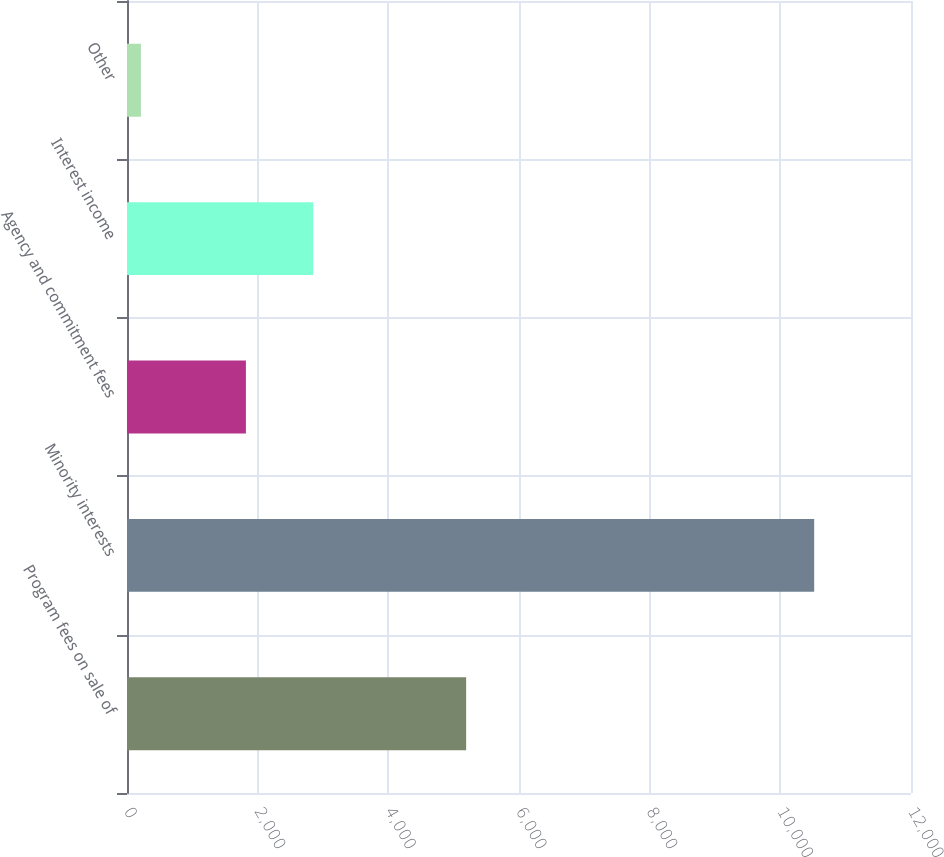<chart> <loc_0><loc_0><loc_500><loc_500><bar_chart><fcel>Program fees on sale of<fcel>Minority interests<fcel>Agency and commitment fees<fcel>Interest income<fcel>Other<nl><fcel>5191<fcel>10518<fcel>1820<fcel>2850.5<fcel>213<nl></chart> 